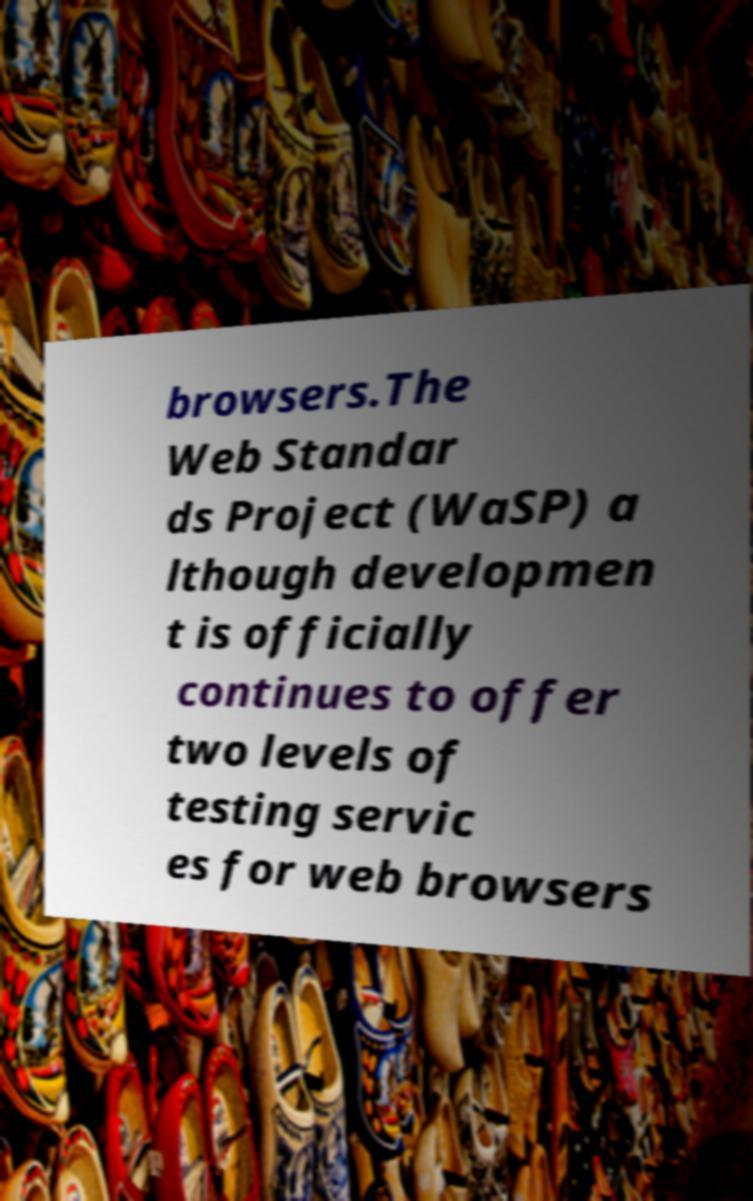Can you accurately transcribe the text from the provided image for me? browsers.The Web Standar ds Project (WaSP) a lthough developmen t is officially continues to offer two levels of testing servic es for web browsers 